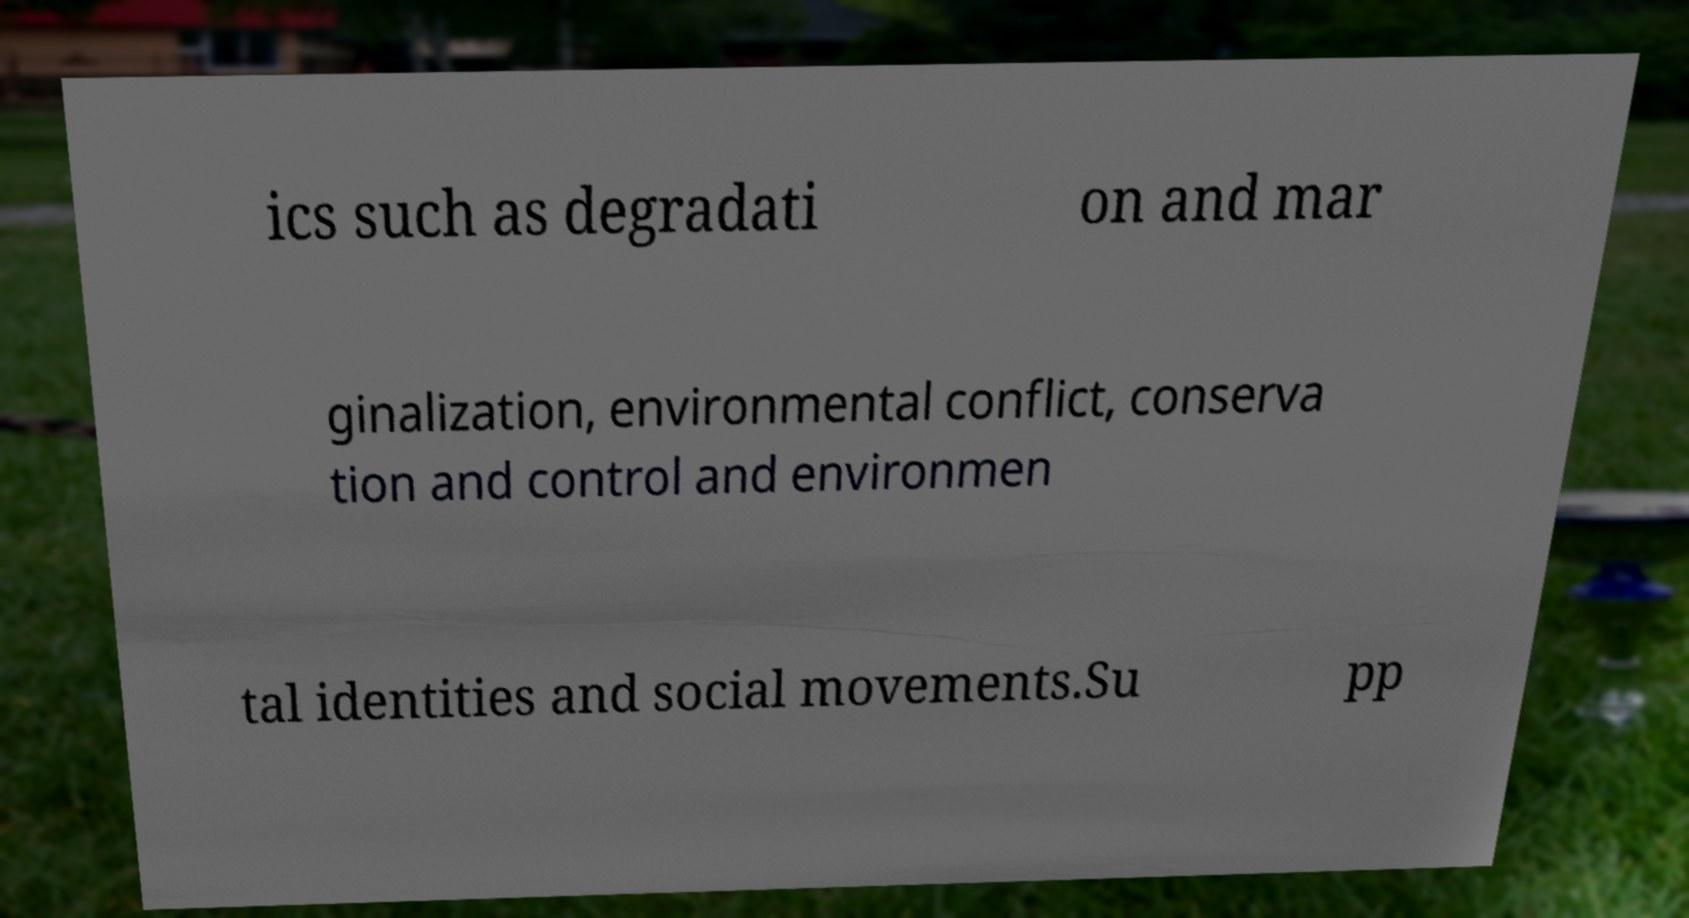Please identify and transcribe the text found in this image. ics such as degradati on and mar ginalization, environmental conflict, conserva tion and control and environmen tal identities and social movements.Su pp 